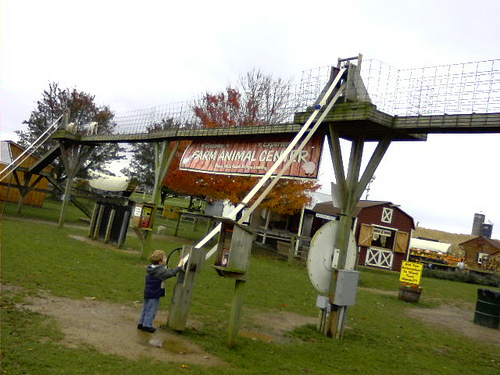<image>
Is the barn under the fence? No. The barn is not positioned under the fence. The vertical relationship between these objects is different. 